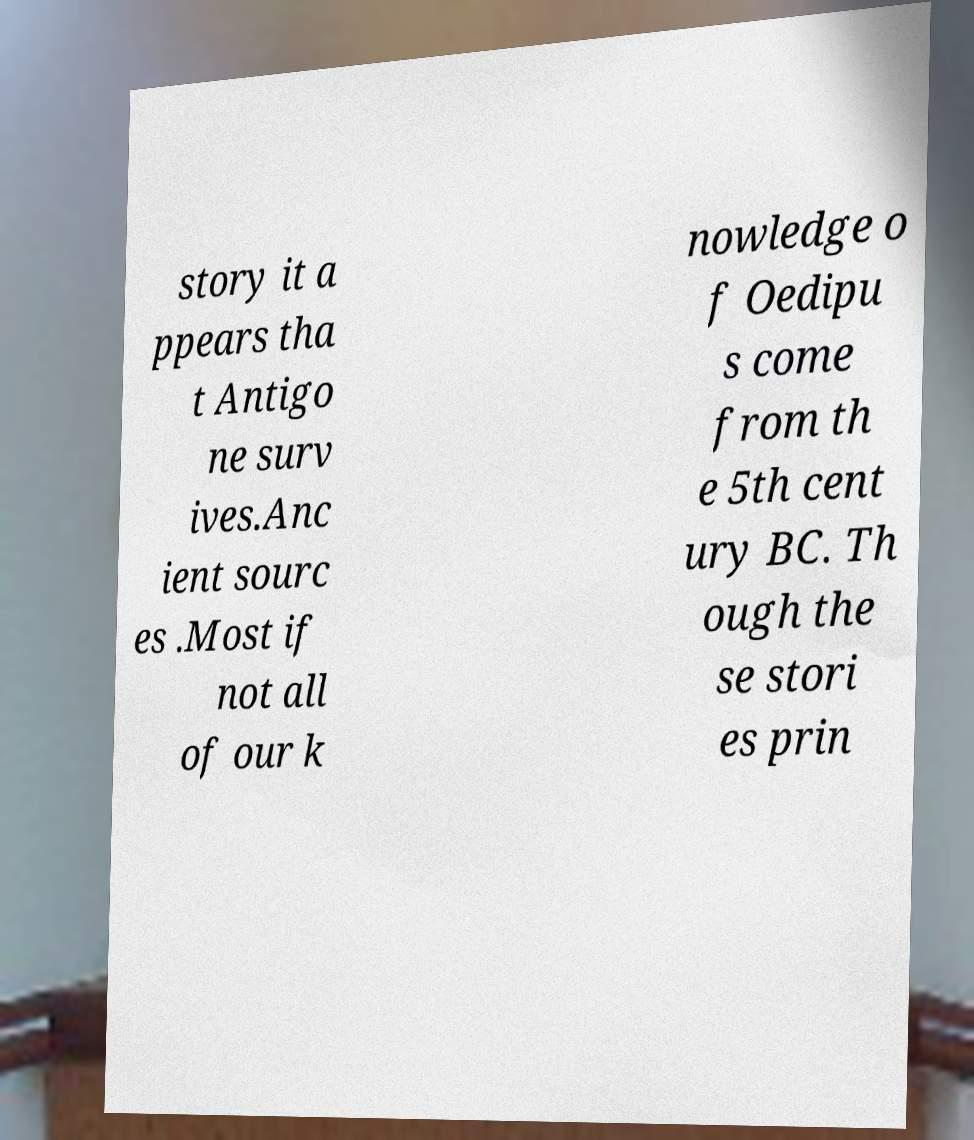Can you accurately transcribe the text from the provided image for me? story it a ppears tha t Antigo ne surv ives.Anc ient sourc es .Most if not all of our k nowledge o f Oedipu s come from th e 5th cent ury BC. Th ough the se stori es prin 